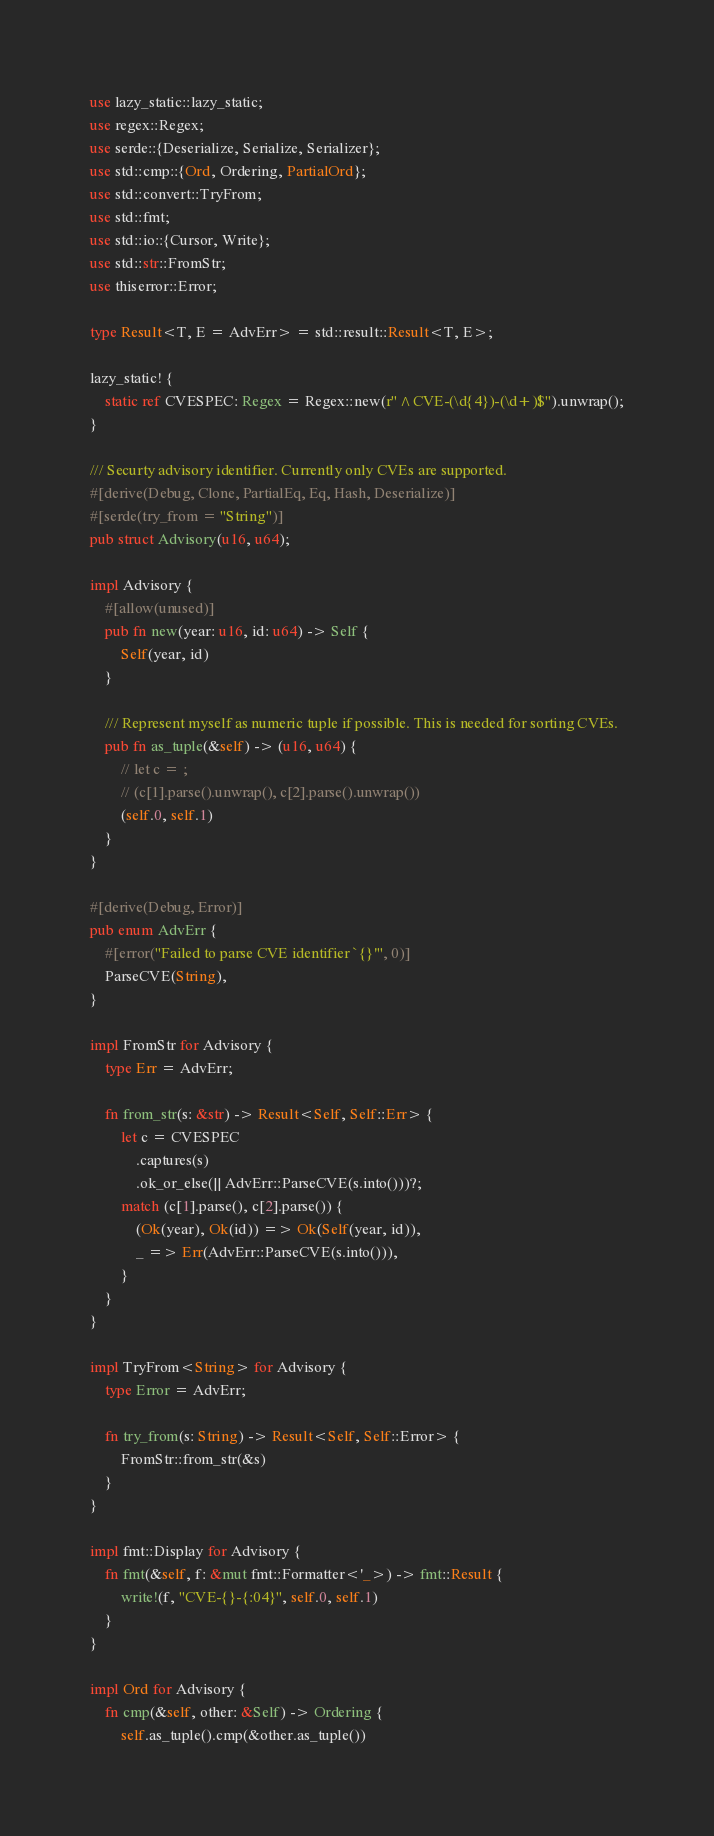<code> <loc_0><loc_0><loc_500><loc_500><_Rust_>use lazy_static::lazy_static;
use regex::Regex;
use serde::{Deserialize, Serialize, Serializer};
use std::cmp::{Ord, Ordering, PartialOrd};
use std::convert::TryFrom;
use std::fmt;
use std::io::{Cursor, Write};
use std::str::FromStr;
use thiserror::Error;

type Result<T, E = AdvErr> = std::result::Result<T, E>;

lazy_static! {
    static ref CVESPEC: Regex = Regex::new(r"^CVE-(\d{4})-(\d+)$").unwrap();
}

/// Securty advisory identifier. Currently only CVEs are supported.
#[derive(Debug, Clone, PartialEq, Eq, Hash, Deserialize)]
#[serde(try_from = "String")]
pub struct Advisory(u16, u64);

impl Advisory {
    #[allow(unused)]
    pub fn new(year: u16, id: u64) -> Self {
        Self(year, id)
    }

    /// Represent myself as numeric tuple if possible. This is needed for sorting CVEs.
    pub fn as_tuple(&self) -> (u16, u64) {
        // let c = ;
        // (c[1].parse().unwrap(), c[2].parse().unwrap())
        (self.0, self.1)
    }
}

#[derive(Debug, Error)]
pub enum AdvErr {
    #[error("Failed to parse CVE identifier `{}'", 0)]
    ParseCVE(String),
}

impl FromStr for Advisory {
    type Err = AdvErr;

    fn from_str(s: &str) -> Result<Self, Self::Err> {
        let c = CVESPEC
            .captures(s)
            .ok_or_else(|| AdvErr::ParseCVE(s.into()))?;
        match (c[1].parse(), c[2].parse()) {
            (Ok(year), Ok(id)) => Ok(Self(year, id)),
            _ => Err(AdvErr::ParseCVE(s.into())),
        }
    }
}

impl TryFrom<String> for Advisory {
    type Error = AdvErr;

    fn try_from(s: String) -> Result<Self, Self::Error> {
        FromStr::from_str(&s)
    }
}

impl fmt::Display for Advisory {
    fn fmt(&self, f: &mut fmt::Formatter<'_>) -> fmt::Result {
        write!(f, "CVE-{}-{:04}", self.0, self.1)
    }
}

impl Ord for Advisory {
    fn cmp(&self, other: &Self) -> Ordering {
        self.as_tuple().cmp(&other.as_tuple())</code> 